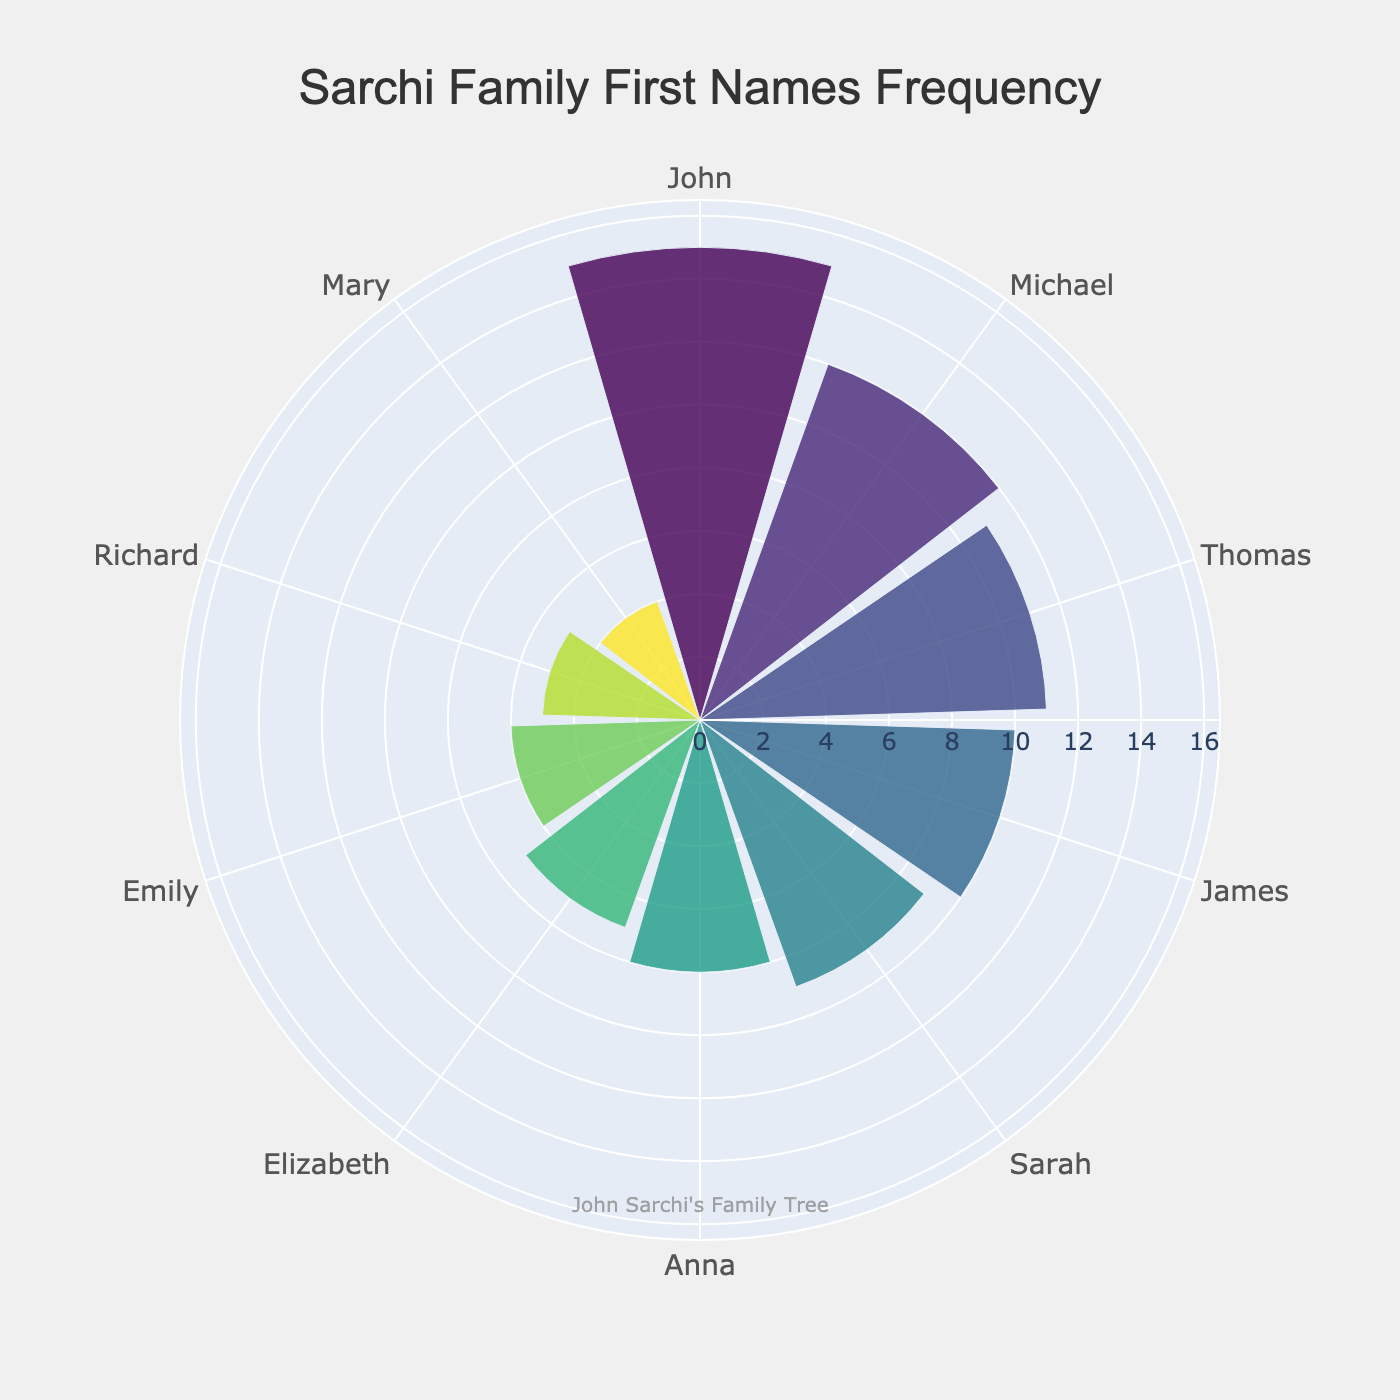How many first names are displayed in the chart? Count the distinct first names listed around the perimeter of the polar area chart.
Answer: 10 What is the title of the chart? Read the text at the top of the chart.
Answer: Sarchi Family First Names Frequency Which first name has the highest frequency? Observe the segment with the largest radius to see the first name associated with it.
Answer: John Which first name has the lowest frequency? Look for the segment with the smallest radius to identify the first name.
Answer: Mary How many more people are named "John" compared to "Richard"? Find the frequencies of "John" and "Richard" and calculate the difference: 15 (John) - 5 (Richard) = 10.
Answer: 10 What is the total frequency of the top three most common first names? Sum the frequencies of the top three first names: John (15), Michael (12), and Thomas (11), which equals 15 + 12 + 11.
Answer: 38 What is the average frequency of all displayed first names? Sum all frequencies and divide by the number of names: (15 + 12 + 11 + 10 + 9 + 8 + 7 + 6 + 5 + 4) / 10 = 87 / 10.
Answer: 8.7 Which first name has a frequency closest to the average frequency of all names? Compare each name’s frequency with the calculated average (8.7) to find the closest one. The closest are Sarah (9) and Anna (8).
Answer: Sarah or Anna Is there any first name frequency that is exactly the midpoint between the highest and lowest frequencies? Calculate the midpoint between the highest (15) and lowest (4) frequencies: (15 + 4) / 2 = 9.5. Check for a frequency equal to 9.
Answer: No Which names have a frequency greater than 10? Identify all segments with radii longer than the 10-frequency mark.
Answer: John, Michael, and Thomas 